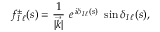<formula> <loc_0><loc_0><loc_500><loc_500>f _ { I \, \ell } ^ { \pm } ( s ) = { \frac { 1 } { | \vec { k } | } } \ e \, ^ { i \delta _ { I \, \ell } ( s ) } \ \sin \delta _ { I \, \ell } ( s ) ,</formula> 